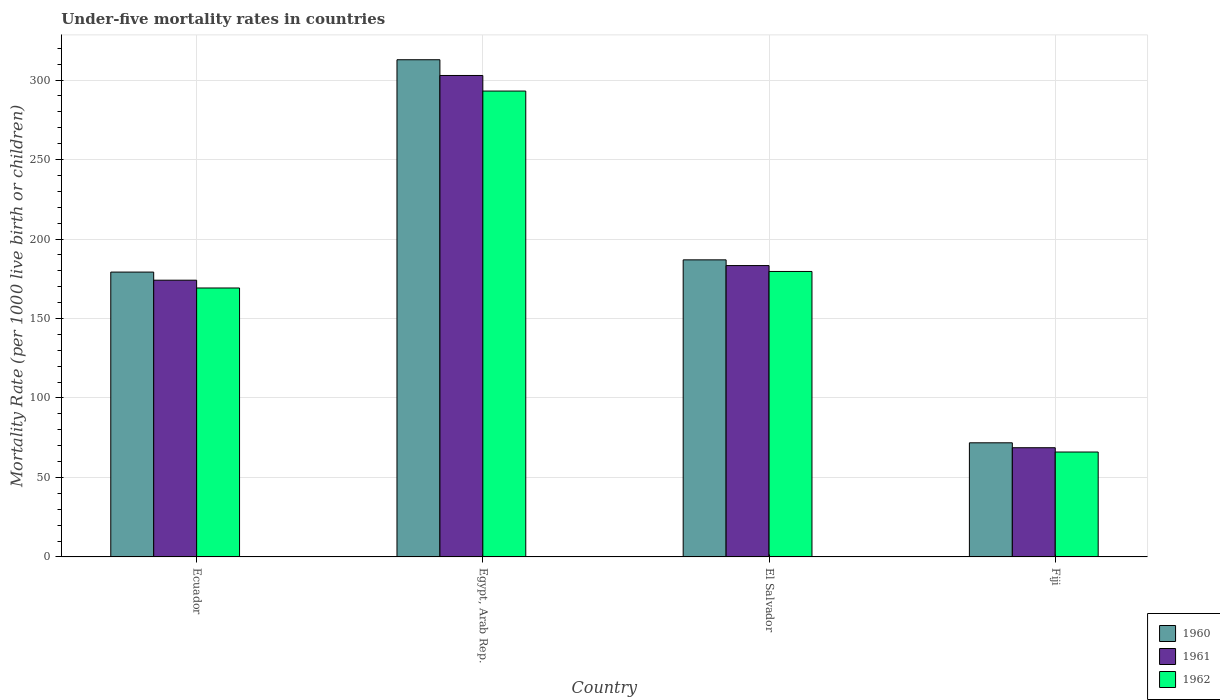What is the label of the 3rd group of bars from the left?
Offer a very short reply. El Salvador. In how many cases, is the number of bars for a given country not equal to the number of legend labels?
Offer a very short reply. 0. What is the under-five mortality rate in 1960 in Fiji?
Your answer should be very brief. 71.8. Across all countries, what is the maximum under-five mortality rate in 1960?
Your response must be concise. 312.8. Across all countries, what is the minimum under-five mortality rate in 1960?
Offer a very short reply. 71.8. In which country was the under-five mortality rate in 1961 maximum?
Make the answer very short. Egypt, Arab Rep. In which country was the under-five mortality rate in 1960 minimum?
Provide a succinct answer. Fiji. What is the total under-five mortality rate in 1961 in the graph?
Give a very brief answer. 729. What is the difference between the under-five mortality rate in 1961 in Ecuador and that in Egypt, Arab Rep.?
Your answer should be compact. -128.8. What is the difference between the under-five mortality rate in 1961 in Fiji and the under-five mortality rate in 1962 in Ecuador?
Ensure brevity in your answer.  -100.5. What is the average under-five mortality rate in 1962 per country?
Give a very brief answer. 176.97. What is the difference between the under-five mortality rate of/in 1961 and under-five mortality rate of/in 1960 in Ecuador?
Ensure brevity in your answer.  -5.1. In how many countries, is the under-five mortality rate in 1960 greater than 70?
Offer a terse response. 4. What is the ratio of the under-five mortality rate in 1960 in Egypt, Arab Rep. to that in El Salvador?
Keep it short and to the point. 1.67. What is the difference between the highest and the second highest under-five mortality rate in 1962?
Offer a very short reply. -10.4. What is the difference between the highest and the lowest under-five mortality rate in 1962?
Provide a short and direct response. 227.1. In how many countries, is the under-five mortality rate in 1961 greater than the average under-five mortality rate in 1961 taken over all countries?
Offer a very short reply. 2. Is the sum of the under-five mortality rate in 1962 in Ecuador and Egypt, Arab Rep. greater than the maximum under-five mortality rate in 1961 across all countries?
Keep it short and to the point. Yes. What does the 3rd bar from the left in Ecuador represents?
Your response must be concise. 1962. Is it the case that in every country, the sum of the under-five mortality rate in 1961 and under-five mortality rate in 1962 is greater than the under-five mortality rate in 1960?
Keep it short and to the point. Yes. Does the graph contain any zero values?
Your answer should be very brief. No. How many legend labels are there?
Make the answer very short. 3. How are the legend labels stacked?
Offer a very short reply. Vertical. What is the title of the graph?
Provide a short and direct response. Under-five mortality rates in countries. Does "1966" appear as one of the legend labels in the graph?
Offer a terse response. No. What is the label or title of the Y-axis?
Your response must be concise. Mortality Rate (per 1000 live birth or children). What is the Mortality Rate (per 1000 live birth or children) of 1960 in Ecuador?
Provide a succinct answer. 179.2. What is the Mortality Rate (per 1000 live birth or children) in 1961 in Ecuador?
Keep it short and to the point. 174.1. What is the Mortality Rate (per 1000 live birth or children) of 1962 in Ecuador?
Provide a short and direct response. 169.2. What is the Mortality Rate (per 1000 live birth or children) in 1960 in Egypt, Arab Rep.?
Keep it short and to the point. 312.8. What is the Mortality Rate (per 1000 live birth or children) in 1961 in Egypt, Arab Rep.?
Provide a succinct answer. 302.9. What is the Mortality Rate (per 1000 live birth or children) of 1962 in Egypt, Arab Rep.?
Give a very brief answer. 293.1. What is the Mortality Rate (per 1000 live birth or children) of 1960 in El Salvador?
Provide a short and direct response. 186.9. What is the Mortality Rate (per 1000 live birth or children) in 1961 in El Salvador?
Give a very brief answer. 183.3. What is the Mortality Rate (per 1000 live birth or children) of 1962 in El Salvador?
Offer a very short reply. 179.6. What is the Mortality Rate (per 1000 live birth or children) of 1960 in Fiji?
Provide a succinct answer. 71.8. What is the Mortality Rate (per 1000 live birth or children) of 1961 in Fiji?
Make the answer very short. 68.7. What is the Mortality Rate (per 1000 live birth or children) of 1962 in Fiji?
Keep it short and to the point. 66. Across all countries, what is the maximum Mortality Rate (per 1000 live birth or children) of 1960?
Your response must be concise. 312.8. Across all countries, what is the maximum Mortality Rate (per 1000 live birth or children) of 1961?
Make the answer very short. 302.9. Across all countries, what is the maximum Mortality Rate (per 1000 live birth or children) in 1962?
Provide a succinct answer. 293.1. Across all countries, what is the minimum Mortality Rate (per 1000 live birth or children) in 1960?
Offer a very short reply. 71.8. Across all countries, what is the minimum Mortality Rate (per 1000 live birth or children) of 1961?
Ensure brevity in your answer.  68.7. Across all countries, what is the minimum Mortality Rate (per 1000 live birth or children) of 1962?
Make the answer very short. 66. What is the total Mortality Rate (per 1000 live birth or children) in 1960 in the graph?
Give a very brief answer. 750.7. What is the total Mortality Rate (per 1000 live birth or children) of 1961 in the graph?
Offer a terse response. 729. What is the total Mortality Rate (per 1000 live birth or children) in 1962 in the graph?
Your response must be concise. 707.9. What is the difference between the Mortality Rate (per 1000 live birth or children) in 1960 in Ecuador and that in Egypt, Arab Rep.?
Your response must be concise. -133.6. What is the difference between the Mortality Rate (per 1000 live birth or children) of 1961 in Ecuador and that in Egypt, Arab Rep.?
Your answer should be compact. -128.8. What is the difference between the Mortality Rate (per 1000 live birth or children) of 1962 in Ecuador and that in Egypt, Arab Rep.?
Your answer should be compact. -123.9. What is the difference between the Mortality Rate (per 1000 live birth or children) of 1962 in Ecuador and that in El Salvador?
Keep it short and to the point. -10.4. What is the difference between the Mortality Rate (per 1000 live birth or children) of 1960 in Ecuador and that in Fiji?
Provide a succinct answer. 107.4. What is the difference between the Mortality Rate (per 1000 live birth or children) in 1961 in Ecuador and that in Fiji?
Provide a short and direct response. 105.4. What is the difference between the Mortality Rate (per 1000 live birth or children) in 1962 in Ecuador and that in Fiji?
Offer a very short reply. 103.2. What is the difference between the Mortality Rate (per 1000 live birth or children) in 1960 in Egypt, Arab Rep. and that in El Salvador?
Your answer should be very brief. 125.9. What is the difference between the Mortality Rate (per 1000 live birth or children) of 1961 in Egypt, Arab Rep. and that in El Salvador?
Your response must be concise. 119.6. What is the difference between the Mortality Rate (per 1000 live birth or children) in 1962 in Egypt, Arab Rep. and that in El Salvador?
Your response must be concise. 113.5. What is the difference between the Mortality Rate (per 1000 live birth or children) of 1960 in Egypt, Arab Rep. and that in Fiji?
Your answer should be compact. 241. What is the difference between the Mortality Rate (per 1000 live birth or children) in 1961 in Egypt, Arab Rep. and that in Fiji?
Your answer should be compact. 234.2. What is the difference between the Mortality Rate (per 1000 live birth or children) in 1962 in Egypt, Arab Rep. and that in Fiji?
Your answer should be compact. 227.1. What is the difference between the Mortality Rate (per 1000 live birth or children) in 1960 in El Salvador and that in Fiji?
Provide a short and direct response. 115.1. What is the difference between the Mortality Rate (per 1000 live birth or children) in 1961 in El Salvador and that in Fiji?
Offer a terse response. 114.6. What is the difference between the Mortality Rate (per 1000 live birth or children) of 1962 in El Salvador and that in Fiji?
Make the answer very short. 113.6. What is the difference between the Mortality Rate (per 1000 live birth or children) in 1960 in Ecuador and the Mortality Rate (per 1000 live birth or children) in 1961 in Egypt, Arab Rep.?
Your answer should be very brief. -123.7. What is the difference between the Mortality Rate (per 1000 live birth or children) in 1960 in Ecuador and the Mortality Rate (per 1000 live birth or children) in 1962 in Egypt, Arab Rep.?
Your response must be concise. -113.9. What is the difference between the Mortality Rate (per 1000 live birth or children) of 1961 in Ecuador and the Mortality Rate (per 1000 live birth or children) of 1962 in Egypt, Arab Rep.?
Offer a very short reply. -119. What is the difference between the Mortality Rate (per 1000 live birth or children) of 1960 in Ecuador and the Mortality Rate (per 1000 live birth or children) of 1961 in El Salvador?
Your answer should be very brief. -4.1. What is the difference between the Mortality Rate (per 1000 live birth or children) of 1960 in Ecuador and the Mortality Rate (per 1000 live birth or children) of 1962 in El Salvador?
Ensure brevity in your answer.  -0.4. What is the difference between the Mortality Rate (per 1000 live birth or children) of 1961 in Ecuador and the Mortality Rate (per 1000 live birth or children) of 1962 in El Salvador?
Give a very brief answer. -5.5. What is the difference between the Mortality Rate (per 1000 live birth or children) of 1960 in Ecuador and the Mortality Rate (per 1000 live birth or children) of 1961 in Fiji?
Provide a succinct answer. 110.5. What is the difference between the Mortality Rate (per 1000 live birth or children) of 1960 in Ecuador and the Mortality Rate (per 1000 live birth or children) of 1962 in Fiji?
Your answer should be very brief. 113.2. What is the difference between the Mortality Rate (per 1000 live birth or children) of 1961 in Ecuador and the Mortality Rate (per 1000 live birth or children) of 1962 in Fiji?
Offer a very short reply. 108.1. What is the difference between the Mortality Rate (per 1000 live birth or children) in 1960 in Egypt, Arab Rep. and the Mortality Rate (per 1000 live birth or children) in 1961 in El Salvador?
Offer a terse response. 129.5. What is the difference between the Mortality Rate (per 1000 live birth or children) in 1960 in Egypt, Arab Rep. and the Mortality Rate (per 1000 live birth or children) in 1962 in El Salvador?
Provide a short and direct response. 133.2. What is the difference between the Mortality Rate (per 1000 live birth or children) of 1961 in Egypt, Arab Rep. and the Mortality Rate (per 1000 live birth or children) of 1962 in El Salvador?
Your response must be concise. 123.3. What is the difference between the Mortality Rate (per 1000 live birth or children) in 1960 in Egypt, Arab Rep. and the Mortality Rate (per 1000 live birth or children) in 1961 in Fiji?
Give a very brief answer. 244.1. What is the difference between the Mortality Rate (per 1000 live birth or children) of 1960 in Egypt, Arab Rep. and the Mortality Rate (per 1000 live birth or children) of 1962 in Fiji?
Provide a short and direct response. 246.8. What is the difference between the Mortality Rate (per 1000 live birth or children) of 1961 in Egypt, Arab Rep. and the Mortality Rate (per 1000 live birth or children) of 1962 in Fiji?
Your answer should be compact. 236.9. What is the difference between the Mortality Rate (per 1000 live birth or children) of 1960 in El Salvador and the Mortality Rate (per 1000 live birth or children) of 1961 in Fiji?
Make the answer very short. 118.2. What is the difference between the Mortality Rate (per 1000 live birth or children) in 1960 in El Salvador and the Mortality Rate (per 1000 live birth or children) in 1962 in Fiji?
Ensure brevity in your answer.  120.9. What is the difference between the Mortality Rate (per 1000 live birth or children) of 1961 in El Salvador and the Mortality Rate (per 1000 live birth or children) of 1962 in Fiji?
Your answer should be very brief. 117.3. What is the average Mortality Rate (per 1000 live birth or children) of 1960 per country?
Your answer should be compact. 187.68. What is the average Mortality Rate (per 1000 live birth or children) in 1961 per country?
Offer a very short reply. 182.25. What is the average Mortality Rate (per 1000 live birth or children) of 1962 per country?
Provide a succinct answer. 176.97. What is the difference between the Mortality Rate (per 1000 live birth or children) in 1960 and Mortality Rate (per 1000 live birth or children) in 1961 in El Salvador?
Your response must be concise. 3.6. What is the ratio of the Mortality Rate (per 1000 live birth or children) of 1960 in Ecuador to that in Egypt, Arab Rep.?
Offer a very short reply. 0.57. What is the ratio of the Mortality Rate (per 1000 live birth or children) in 1961 in Ecuador to that in Egypt, Arab Rep.?
Offer a terse response. 0.57. What is the ratio of the Mortality Rate (per 1000 live birth or children) in 1962 in Ecuador to that in Egypt, Arab Rep.?
Ensure brevity in your answer.  0.58. What is the ratio of the Mortality Rate (per 1000 live birth or children) of 1960 in Ecuador to that in El Salvador?
Provide a short and direct response. 0.96. What is the ratio of the Mortality Rate (per 1000 live birth or children) of 1961 in Ecuador to that in El Salvador?
Keep it short and to the point. 0.95. What is the ratio of the Mortality Rate (per 1000 live birth or children) of 1962 in Ecuador to that in El Salvador?
Your response must be concise. 0.94. What is the ratio of the Mortality Rate (per 1000 live birth or children) in 1960 in Ecuador to that in Fiji?
Ensure brevity in your answer.  2.5. What is the ratio of the Mortality Rate (per 1000 live birth or children) of 1961 in Ecuador to that in Fiji?
Give a very brief answer. 2.53. What is the ratio of the Mortality Rate (per 1000 live birth or children) of 1962 in Ecuador to that in Fiji?
Make the answer very short. 2.56. What is the ratio of the Mortality Rate (per 1000 live birth or children) in 1960 in Egypt, Arab Rep. to that in El Salvador?
Provide a short and direct response. 1.67. What is the ratio of the Mortality Rate (per 1000 live birth or children) in 1961 in Egypt, Arab Rep. to that in El Salvador?
Give a very brief answer. 1.65. What is the ratio of the Mortality Rate (per 1000 live birth or children) in 1962 in Egypt, Arab Rep. to that in El Salvador?
Ensure brevity in your answer.  1.63. What is the ratio of the Mortality Rate (per 1000 live birth or children) in 1960 in Egypt, Arab Rep. to that in Fiji?
Provide a succinct answer. 4.36. What is the ratio of the Mortality Rate (per 1000 live birth or children) of 1961 in Egypt, Arab Rep. to that in Fiji?
Provide a short and direct response. 4.41. What is the ratio of the Mortality Rate (per 1000 live birth or children) of 1962 in Egypt, Arab Rep. to that in Fiji?
Keep it short and to the point. 4.44. What is the ratio of the Mortality Rate (per 1000 live birth or children) of 1960 in El Salvador to that in Fiji?
Provide a succinct answer. 2.6. What is the ratio of the Mortality Rate (per 1000 live birth or children) of 1961 in El Salvador to that in Fiji?
Your answer should be compact. 2.67. What is the ratio of the Mortality Rate (per 1000 live birth or children) of 1962 in El Salvador to that in Fiji?
Ensure brevity in your answer.  2.72. What is the difference between the highest and the second highest Mortality Rate (per 1000 live birth or children) in 1960?
Provide a short and direct response. 125.9. What is the difference between the highest and the second highest Mortality Rate (per 1000 live birth or children) of 1961?
Ensure brevity in your answer.  119.6. What is the difference between the highest and the second highest Mortality Rate (per 1000 live birth or children) of 1962?
Your response must be concise. 113.5. What is the difference between the highest and the lowest Mortality Rate (per 1000 live birth or children) in 1960?
Ensure brevity in your answer.  241. What is the difference between the highest and the lowest Mortality Rate (per 1000 live birth or children) of 1961?
Give a very brief answer. 234.2. What is the difference between the highest and the lowest Mortality Rate (per 1000 live birth or children) in 1962?
Offer a terse response. 227.1. 